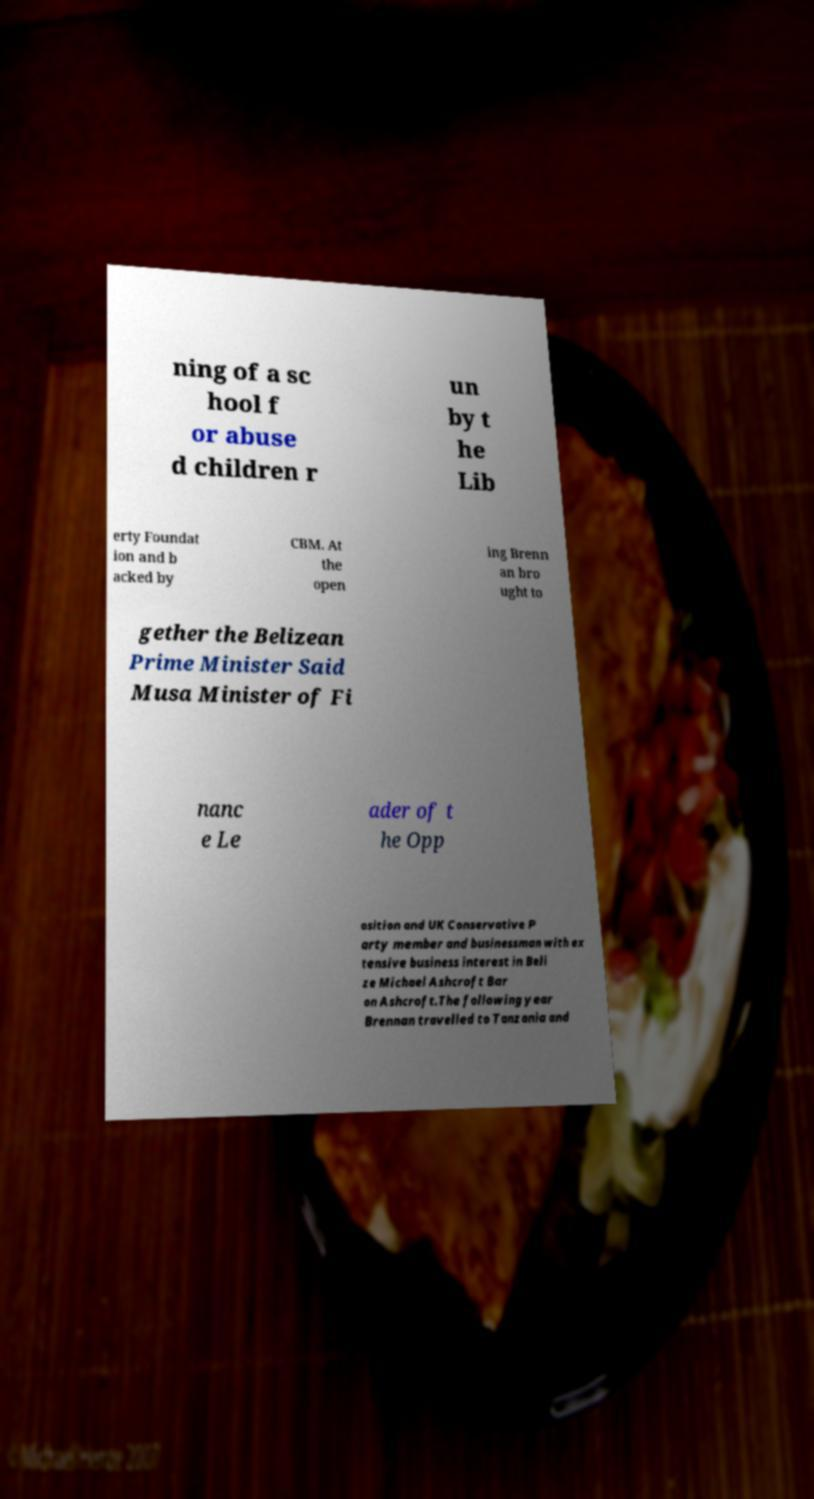Could you extract and type out the text from this image? ning of a sc hool f or abuse d children r un by t he Lib erty Foundat ion and b acked by CBM. At the open ing Brenn an bro ught to gether the Belizean Prime Minister Said Musa Minister of Fi nanc e Le ader of t he Opp osition and UK Conservative P arty member and businessman with ex tensive business interest in Beli ze Michael Ashcroft Bar on Ashcroft.The following year Brennan travelled to Tanzania and 